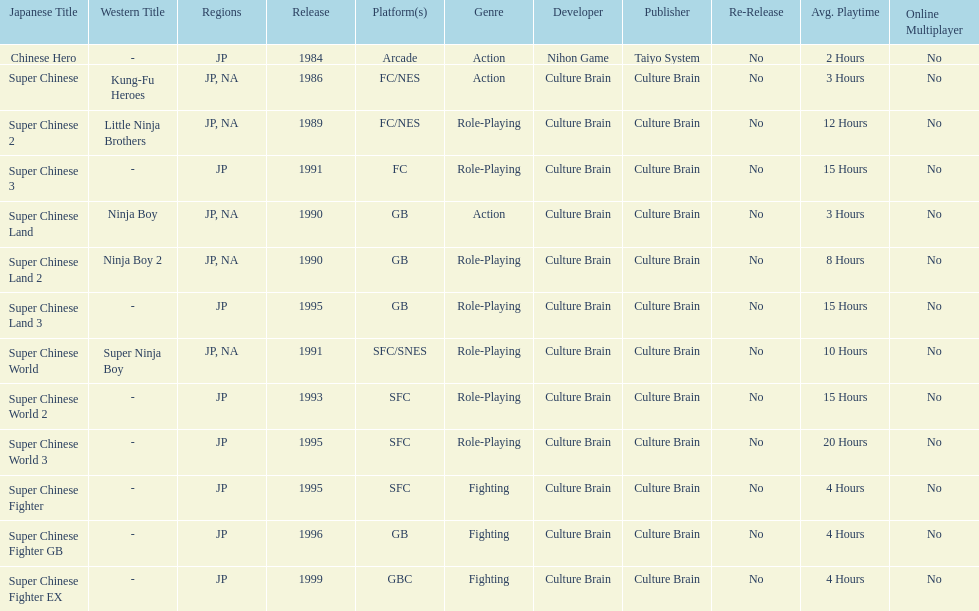Which platforms had the most titles released? GB. 